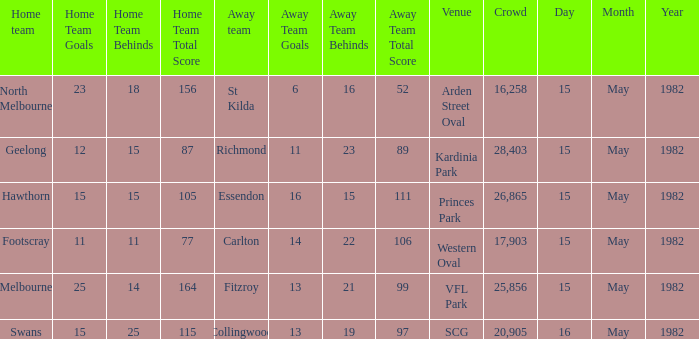Which home team played against the away team with a score of 13.19 (97)? Swans. 